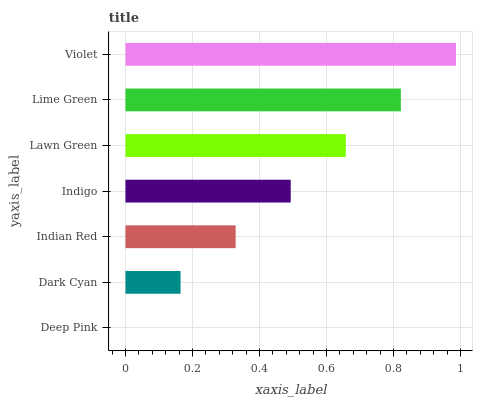Is Deep Pink the minimum?
Answer yes or no. Yes. Is Violet the maximum?
Answer yes or no. Yes. Is Dark Cyan the minimum?
Answer yes or no. No. Is Dark Cyan the maximum?
Answer yes or no. No. Is Dark Cyan greater than Deep Pink?
Answer yes or no. Yes. Is Deep Pink less than Dark Cyan?
Answer yes or no. Yes. Is Deep Pink greater than Dark Cyan?
Answer yes or no. No. Is Dark Cyan less than Deep Pink?
Answer yes or no. No. Is Indigo the high median?
Answer yes or no. Yes. Is Indigo the low median?
Answer yes or no. Yes. Is Violet the high median?
Answer yes or no. No. Is Indian Red the low median?
Answer yes or no. No. 